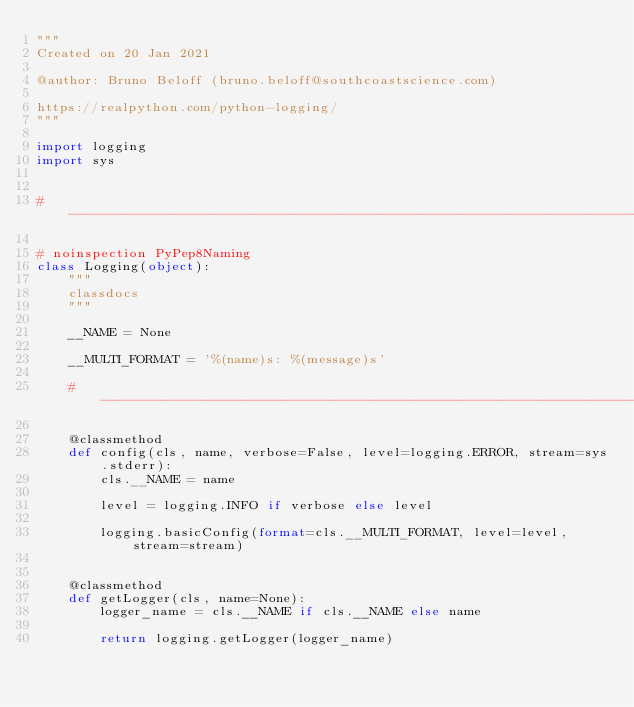Convert code to text. <code><loc_0><loc_0><loc_500><loc_500><_Python_>"""
Created on 20 Jan 2021

@author: Bruno Beloff (bruno.beloff@southcoastscience.com)

https://realpython.com/python-logging/
"""

import logging
import sys


# --------------------------------------------------------------------------------------------------------------------

# noinspection PyPep8Naming
class Logging(object):
    """
    classdocs
    """

    __NAME = None

    __MULTI_FORMAT = '%(name)s: %(message)s'

    # ----------------------------------------------------------------------------------------------------------------

    @classmethod
    def config(cls, name, verbose=False, level=logging.ERROR, stream=sys.stderr):
        cls.__NAME = name

        level = logging.INFO if verbose else level

        logging.basicConfig(format=cls.__MULTI_FORMAT, level=level, stream=stream)


    @classmethod
    def getLogger(cls, name=None):
        logger_name = cls.__NAME if cls.__NAME else name

        return logging.getLogger(logger_name)
</code> 